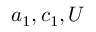<formula> <loc_0><loc_0><loc_500><loc_500>a _ { 1 } , c _ { 1 } , U</formula> 